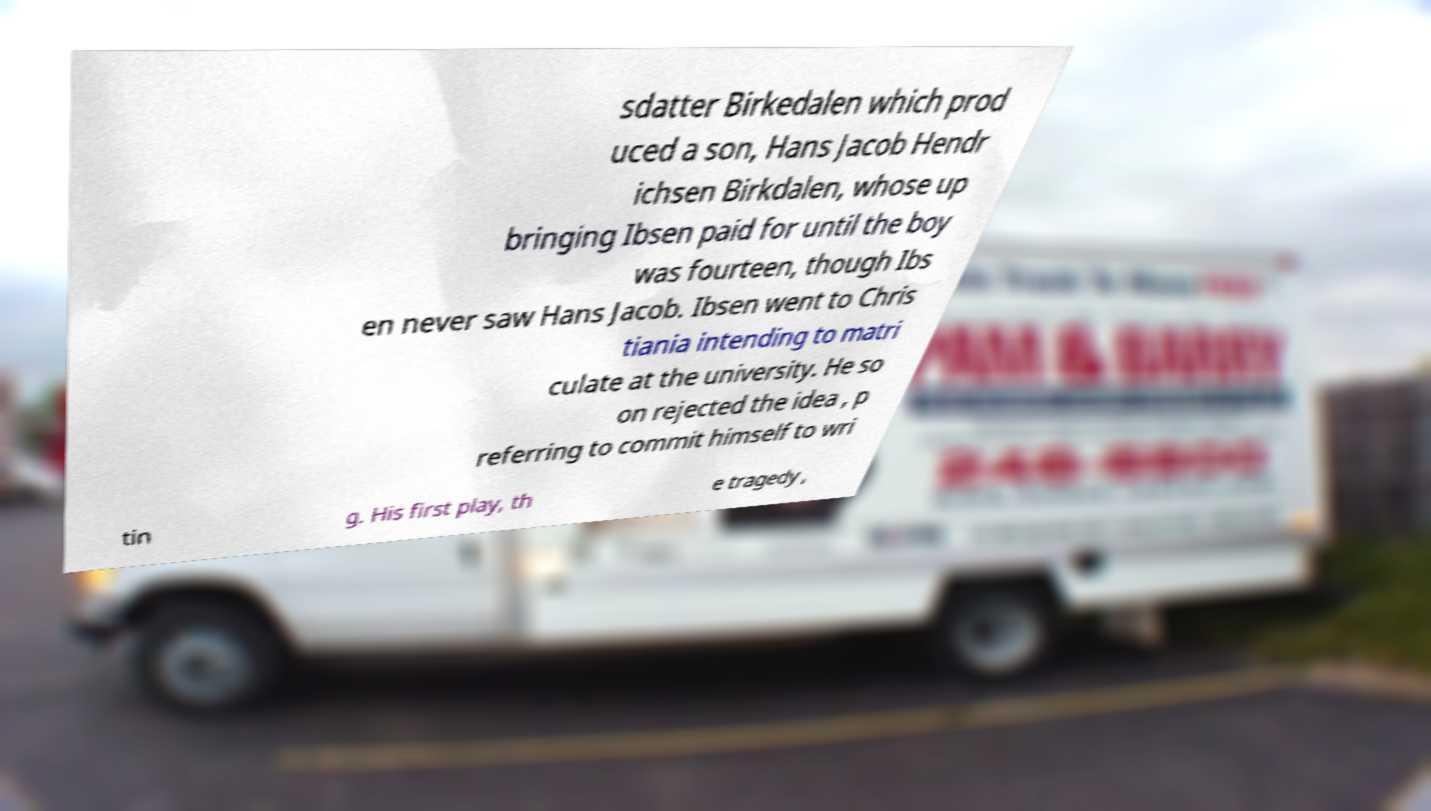Please identify and transcribe the text found in this image. sdatter Birkedalen which prod uced a son, Hans Jacob Hendr ichsen Birkdalen, whose up bringing Ibsen paid for until the boy was fourteen, though Ibs en never saw Hans Jacob. Ibsen went to Chris tiania intending to matri culate at the university. He so on rejected the idea , p referring to commit himself to wri tin g. His first play, th e tragedy , 